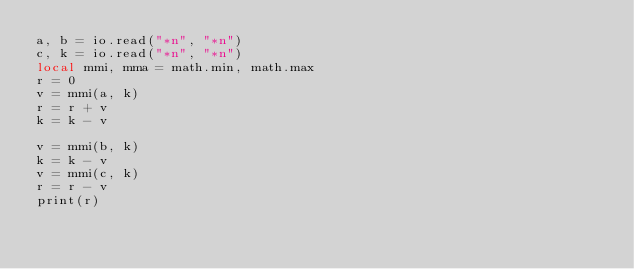<code> <loc_0><loc_0><loc_500><loc_500><_Lua_>a, b = io.read("*n", "*n")
c, k = io.read("*n", "*n")
local mmi, mma = math.min, math.max
r = 0
v = mmi(a, k)
r = r + v
k = k - v

v = mmi(b, k)
k = k - v
v = mmi(c, k)
r = r - v
print(r)
</code> 